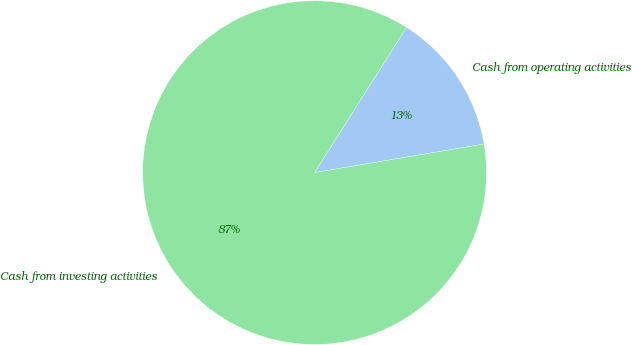Convert chart. <chart><loc_0><loc_0><loc_500><loc_500><pie_chart><fcel>Cash from operating activities<fcel>Cash from investing activities<nl><fcel>13.36%<fcel>86.64%<nl></chart> 